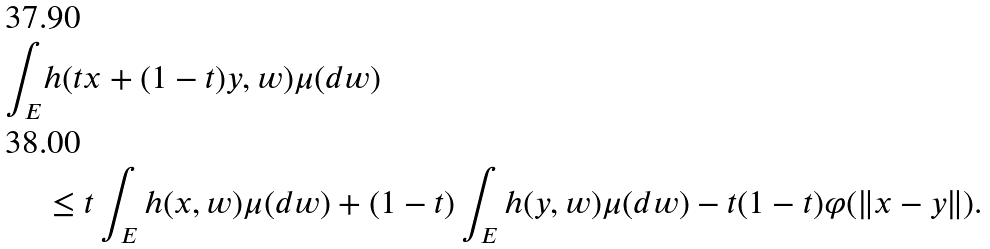<formula> <loc_0><loc_0><loc_500><loc_500>\int _ { E } & h ( t x + ( 1 - t ) y , w ) \mu ( d w ) \\ & \leq t \int _ { E } h ( x , w ) \mu ( d w ) + ( 1 - t ) \int _ { E } h ( y , w ) \mu ( d w ) - t ( 1 - t ) \varphi ( \| x - y \| ) .</formula> 